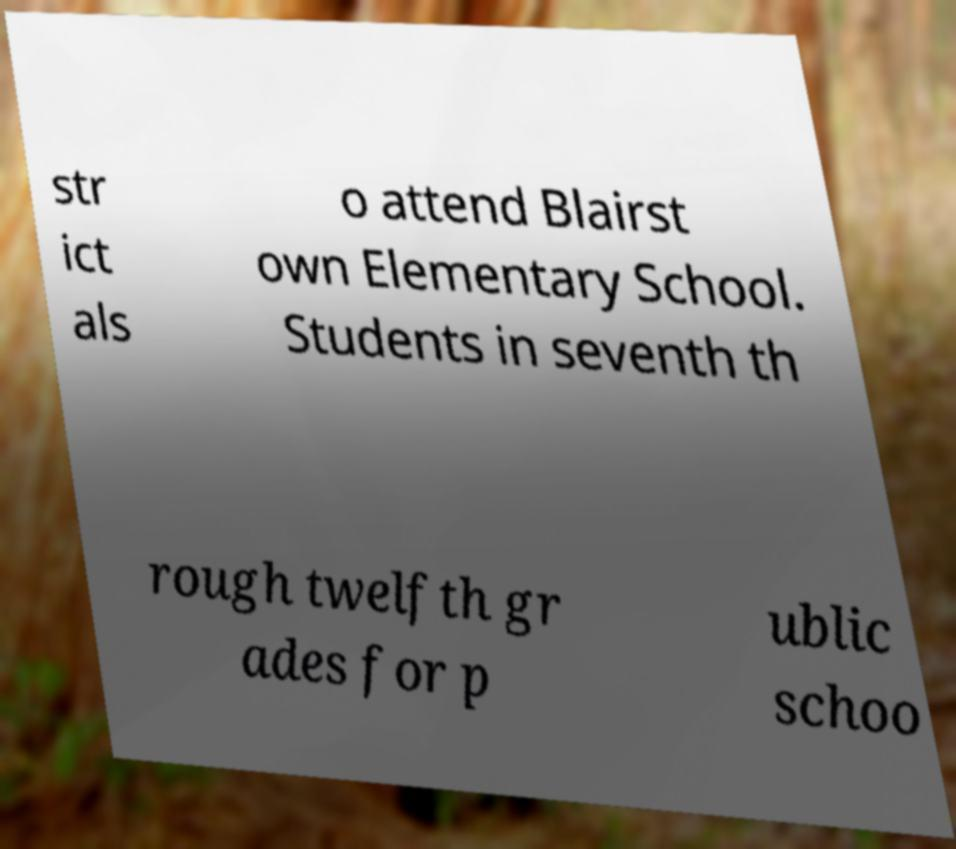Can you read and provide the text displayed in the image?This photo seems to have some interesting text. Can you extract and type it out for me? str ict als o attend Blairst own Elementary School. Students in seventh th rough twelfth gr ades for p ublic schoo 